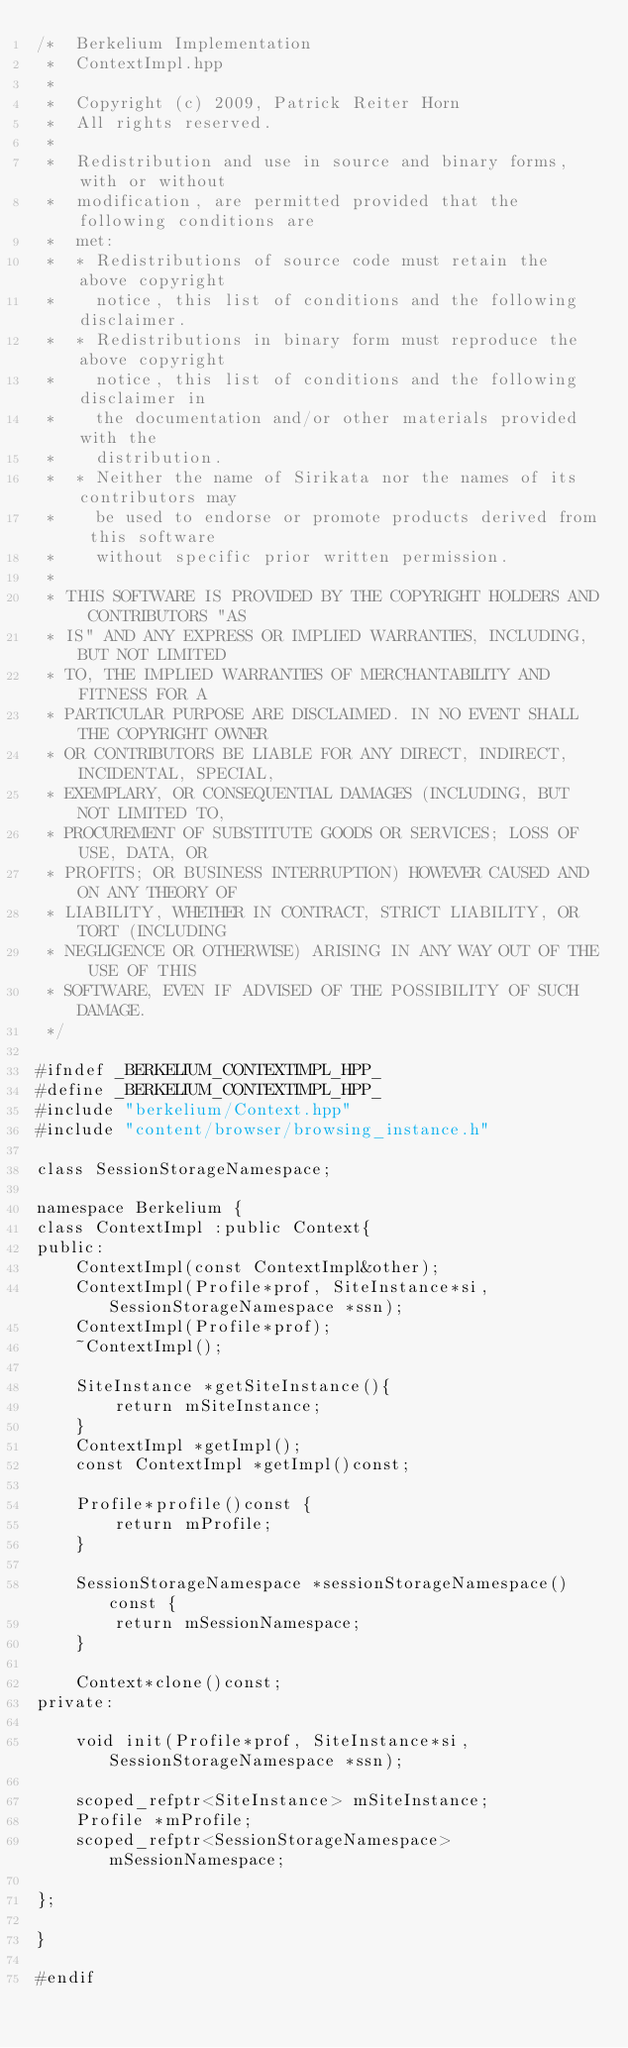<code> <loc_0><loc_0><loc_500><loc_500><_C++_>/*  Berkelium Implementation
 *  ContextImpl.hpp
 *
 *  Copyright (c) 2009, Patrick Reiter Horn
 *  All rights reserved.
 *
 *  Redistribution and use in source and binary forms, with or without
 *  modification, are permitted provided that the following conditions are
 *  met:
 *  * Redistributions of source code must retain the above copyright
 *    notice, this list of conditions and the following disclaimer.
 *  * Redistributions in binary form must reproduce the above copyright
 *    notice, this list of conditions and the following disclaimer in
 *    the documentation and/or other materials provided with the
 *    distribution.
 *  * Neither the name of Sirikata nor the names of its contributors may
 *    be used to endorse or promote products derived from this software
 *    without specific prior written permission.
 *
 * THIS SOFTWARE IS PROVIDED BY THE COPYRIGHT HOLDERS AND CONTRIBUTORS "AS
 * IS" AND ANY EXPRESS OR IMPLIED WARRANTIES, INCLUDING, BUT NOT LIMITED
 * TO, THE IMPLIED WARRANTIES OF MERCHANTABILITY AND FITNESS FOR A
 * PARTICULAR PURPOSE ARE DISCLAIMED. IN NO EVENT SHALL THE COPYRIGHT OWNER
 * OR CONTRIBUTORS BE LIABLE FOR ANY DIRECT, INDIRECT, INCIDENTAL, SPECIAL,
 * EXEMPLARY, OR CONSEQUENTIAL DAMAGES (INCLUDING, BUT NOT LIMITED TO,
 * PROCUREMENT OF SUBSTITUTE GOODS OR SERVICES; LOSS OF USE, DATA, OR
 * PROFITS; OR BUSINESS INTERRUPTION) HOWEVER CAUSED AND ON ANY THEORY OF
 * LIABILITY, WHETHER IN CONTRACT, STRICT LIABILITY, OR TORT (INCLUDING
 * NEGLIGENCE OR OTHERWISE) ARISING IN ANY WAY OUT OF THE USE OF THIS
 * SOFTWARE, EVEN IF ADVISED OF THE POSSIBILITY OF SUCH DAMAGE.
 */

#ifndef _BERKELIUM_CONTEXTIMPL_HPP_
#define _BERKELIUM_CONTEXTIMPL_HPP_
#include "berkelium/Context.hpp"
#include "content/browser/browsing_instance.h"

class SessionStorageNamespace;

namespace Berkelium {
class ContextImpl :public Context{
public:
    ContextImpl(const ContextImpl&other);
    ContextImpl(Profile*prof, SiteInstance*si, SessionStorageNamespace *ssn);
    ContextImpl(Profile*prof);
    ~ContextImpl();

    SiteInstance *getSiteInstance(){
        return mSiteInstance;
    }
    ContextImpl *getImpl();
    const ContextImpl *getImpl()const;

    Profile*profile()const {
        return mProfile;
    }

    SessionStorageNamespace *sessionStorageNamespace()const {
        return mSessionNamespace;
    }

    Context*clone()const;
private:

    void init(Profile*prof, SiteInstance*si, SessionStorageNamespace *ssn);

    scoped_refptr<SiteInstance> mSiteInstance;
    Profile *mProfile;
    scoped_refptr<SessionStorageNamespace> mSessionNamespace;
    
};

}

#endif
</code> 